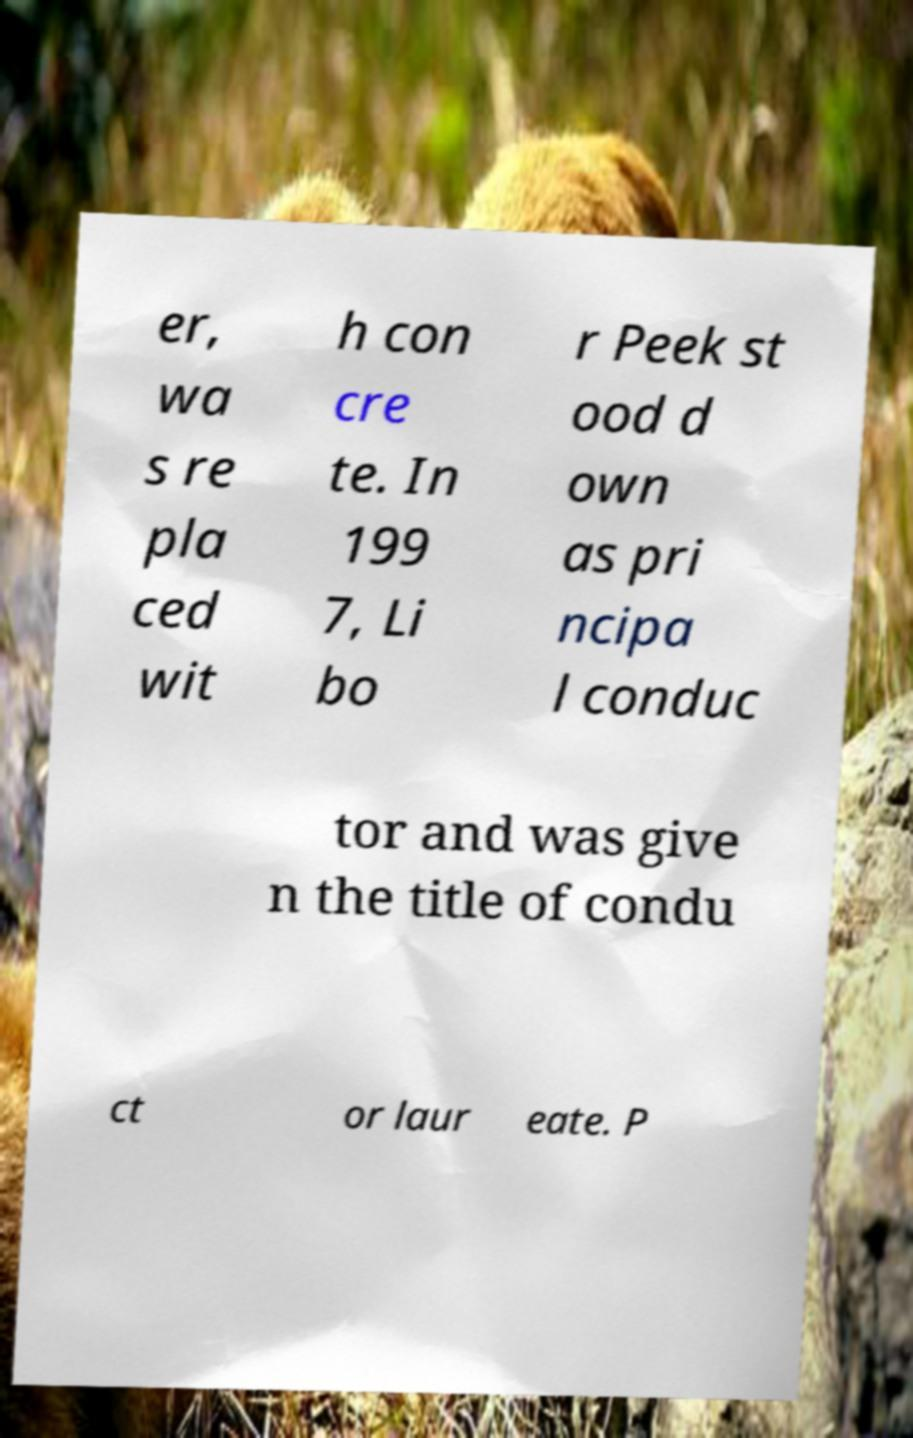There's text embedded in this image that I need extracted. Can you transcribe it verbatim? er, wa s re pla ced wit h con cre te. In 199 7, Li bo r Peek st ood d own as pri ncipa l conduc tor and was give n the title of condu ct or laur eate. P 